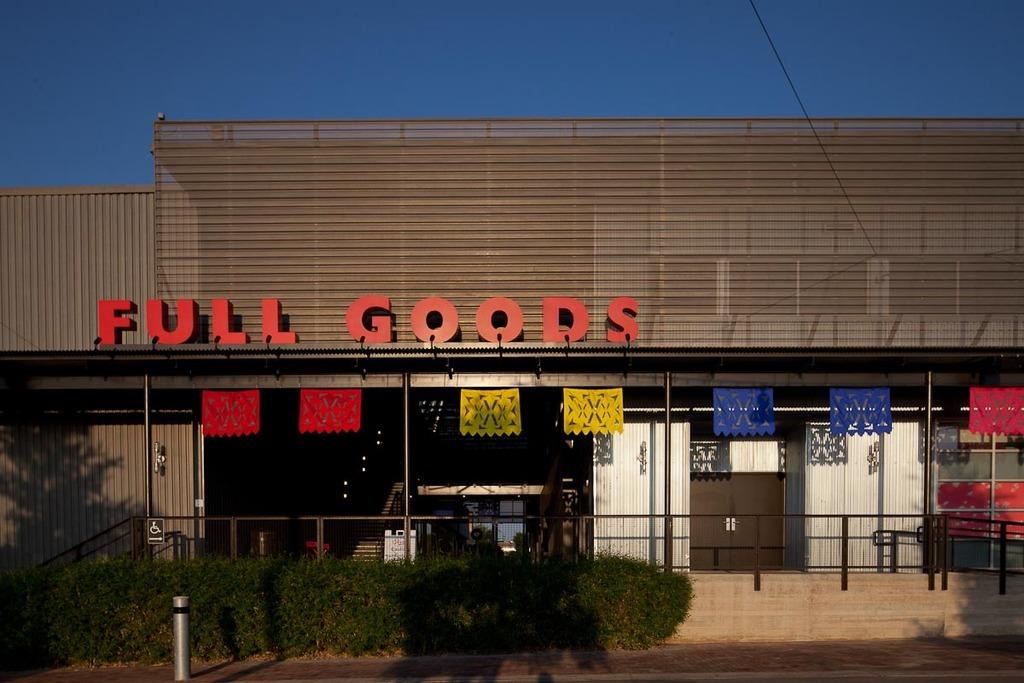What type of vegetation can be seen in the image? There are shrubs in the image. What material is the railing made of in the image? The railing in the image is made of steel. What type of structure is present in the image? There is a building in the image. What is the color of the name board in the image? The name board in the image is in red color. What color is the sky in the background of the image? The sky in the background of the image is blue. Can you hear the bells ringing in the image? There are no bells present in the image, so it is not possible to hear them ringing. 